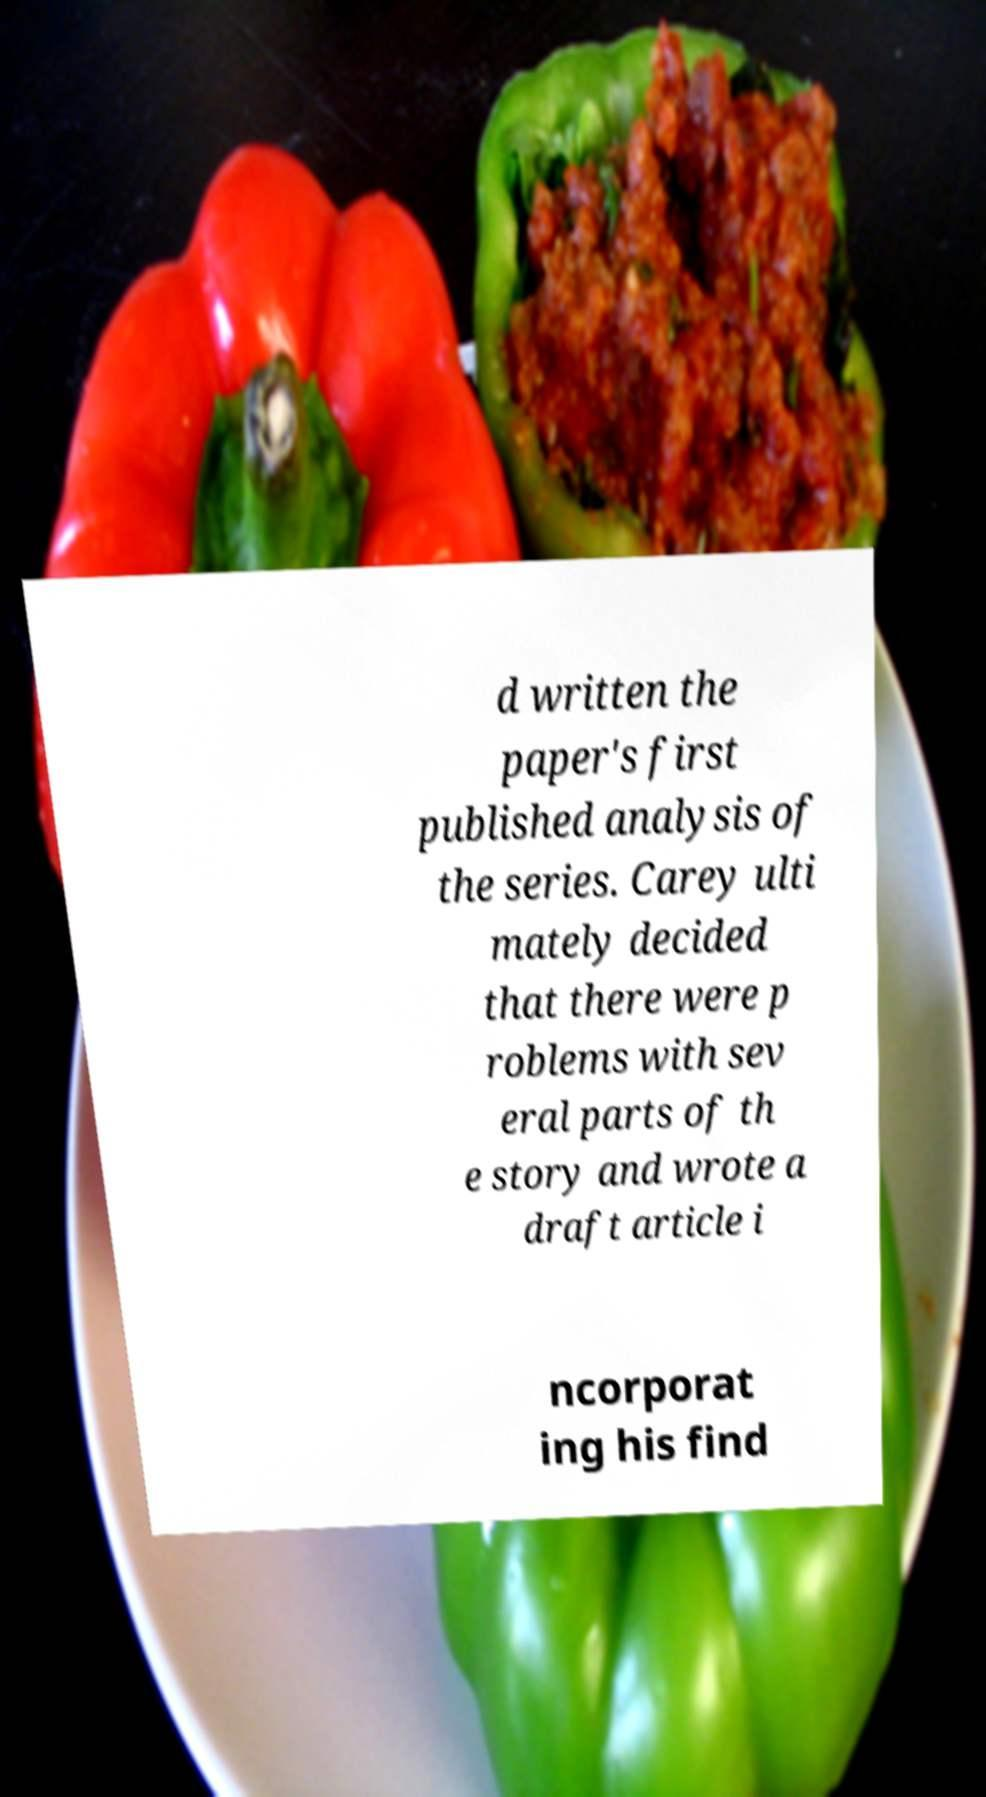Can you accurately transcribe the text from the provided image for me? d written the paper's first published analysis of the series. Carey ulti mately decided that there were p roblems with sev eral parts of th e story and wrote a draft article i ncorporat ing his find 